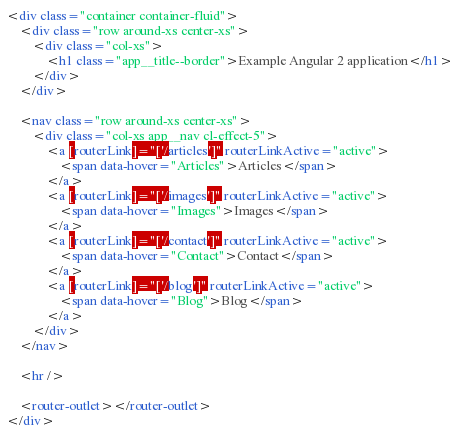Convert code to text. <code><loc_0><loc_0><loc_500><loc_500><_HTML_><div class="container container-fluid">
    <div class="row around-xs center-xs">
        <div class="col-xs">
            <h1 class="app__title--border">Example Angular 2 application</h1>
        </div>
    </div>

    <nav class="row around-xs center-xs">
        <div class="col-xs app__nav cl-effect-5">
            <a [routerLink]="['/articles']" routerLinkActive="active">
                <span data-hover="Articles">Articles</span>
            </a>
            <a [routerLink]="['/images']" routerLinkActive="active">
                <span data-hover="Images">Images</span>
            </a>
            <a [routerLink]="['/contact']" routerLinkActive="active">
                <span data-hover="Contact">Contact</span>
            </a>
            <a [routerLink]="['/blog']" routerLinkActive="active">
                <span data-hover="Blog">Blog</span>
            </a>
        </div>
    </nav>

    <hr />

    <router-outlet></router-outlet>
</div>
</code> 